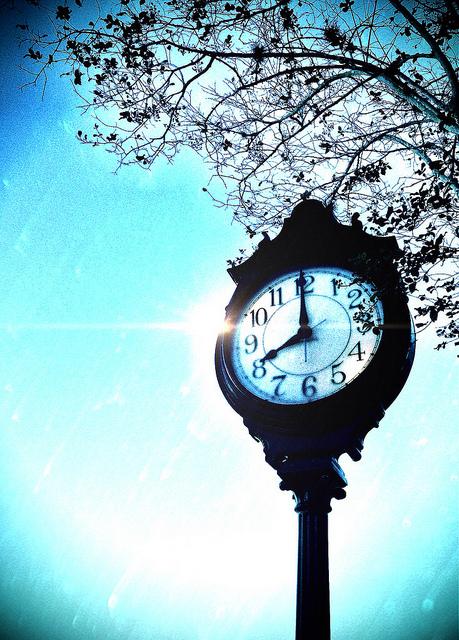What is directly above the clock?
Short answer required. Tree. Does the clock read 8 am?
Give a very brief answer. Yes. Is this a typical clock you would see in an American park?
Be succinct. No. 